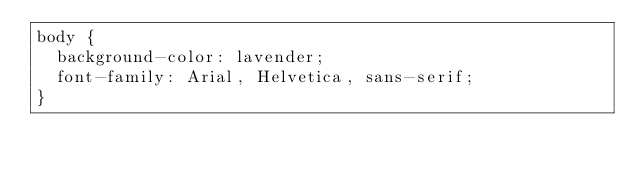<code> <loc_0><loc_0><loc_500><loc_500><_CSS_>body {
	background-color: lavender;
	font-family: Arial, Helvetica, sans-serif;
}</code> 